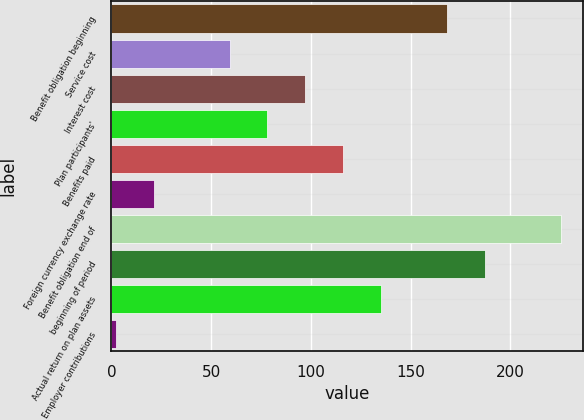<chart> <loc_0><loc_0><loc_500><loc_500><bar_chart><fcel>Benefit obligation beginning<fcel>Service cost<fcel>Interest cost<fcel>Plan participants'<fcel>Benefits paid<fcel>Foreign currency exchange rate<fcel>Benefit obligation end of<fcel>beginning of period<fcel>Actual return on plan assets<fcel>Employer contributions<nl><fcel>168.2<fcel>59.2<fcel>97.2<fcel>78.2<fcel>116.2<fcel>21.2<fcel>225.2<fcel>187.2<fcel>135.2<fcel>2.2<nl></chart> 